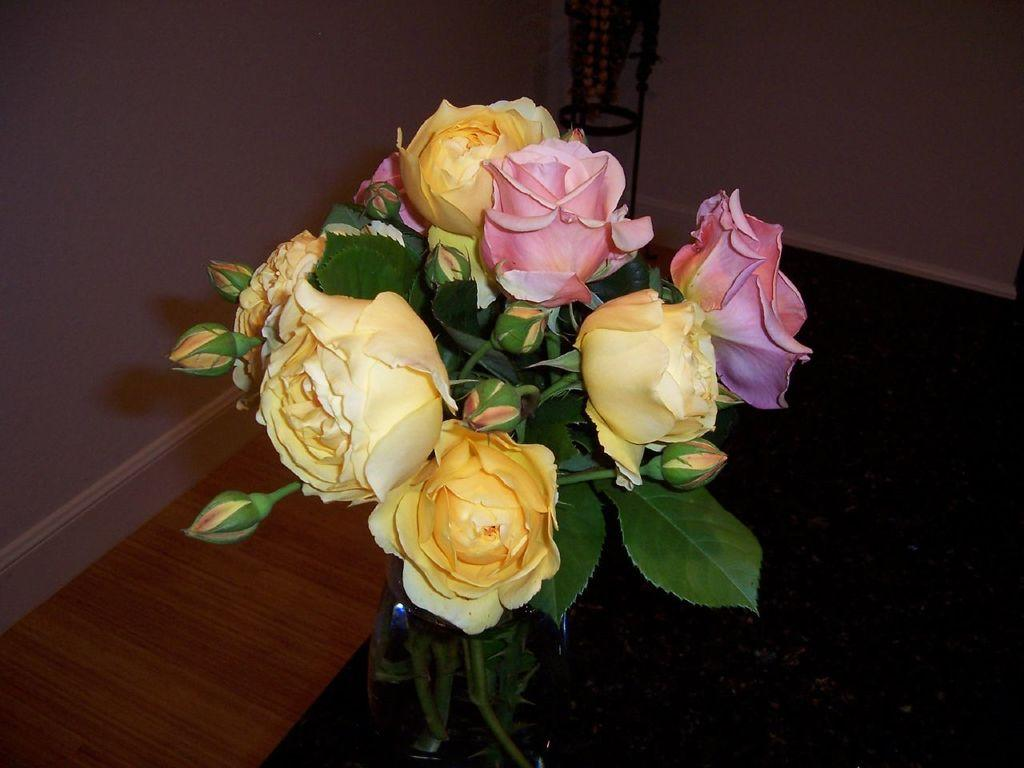What is the main object in the image? There is a flower vase in the image. What is inside the vase? The vase contains flowers, buds, and leaves. Where is the vase located? The vase is on a table. Is there any other furniture or structure in the image? Yes, there is a stand near the wall in the image. What type of quill is being used to adjust the flowers in the vase? There is no quill or adjustment being made to the flowers in the vase in the image. How many chairs are visible in the image? There are no chairs visible in the image. 